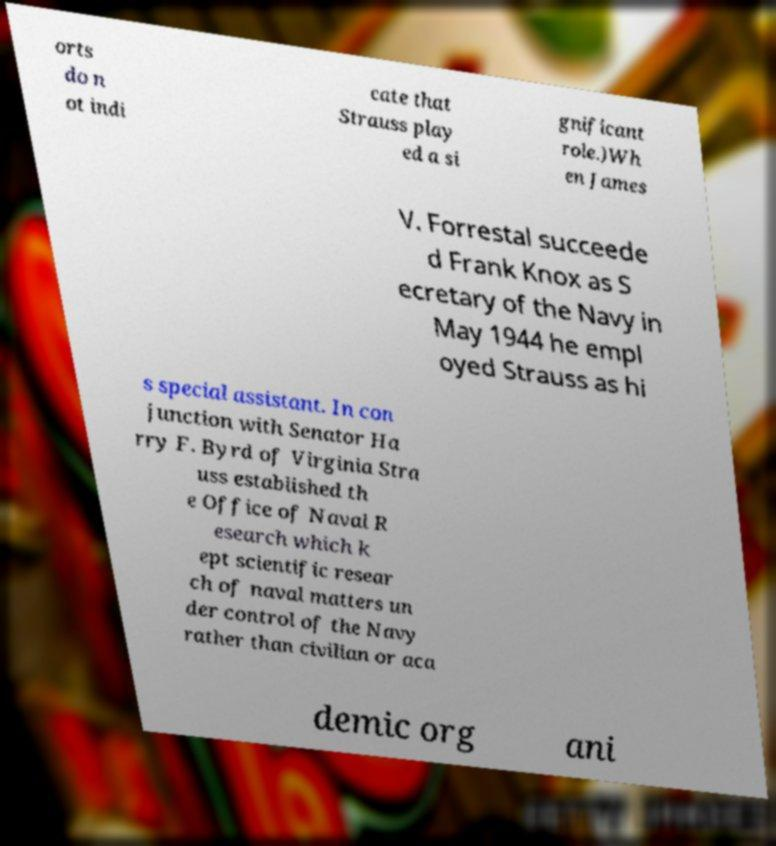Please identify and transcribe the text found in this image. orts do n ot indi cate that Strauss play ed a si gnificant role.)Wh en James V. Forrestal succeede d Frank Knox as S ecretary of the Navy in May 1944 he empl oyed Strauss as hi s special assistant. In con junction with Senator Ha rry F. Byrd of Virginia Stra uss established th e Office of Naval R esearch which k ept scientific resear ch of naval matters un der control of the Navy rather than civilian or aca demic org ani 